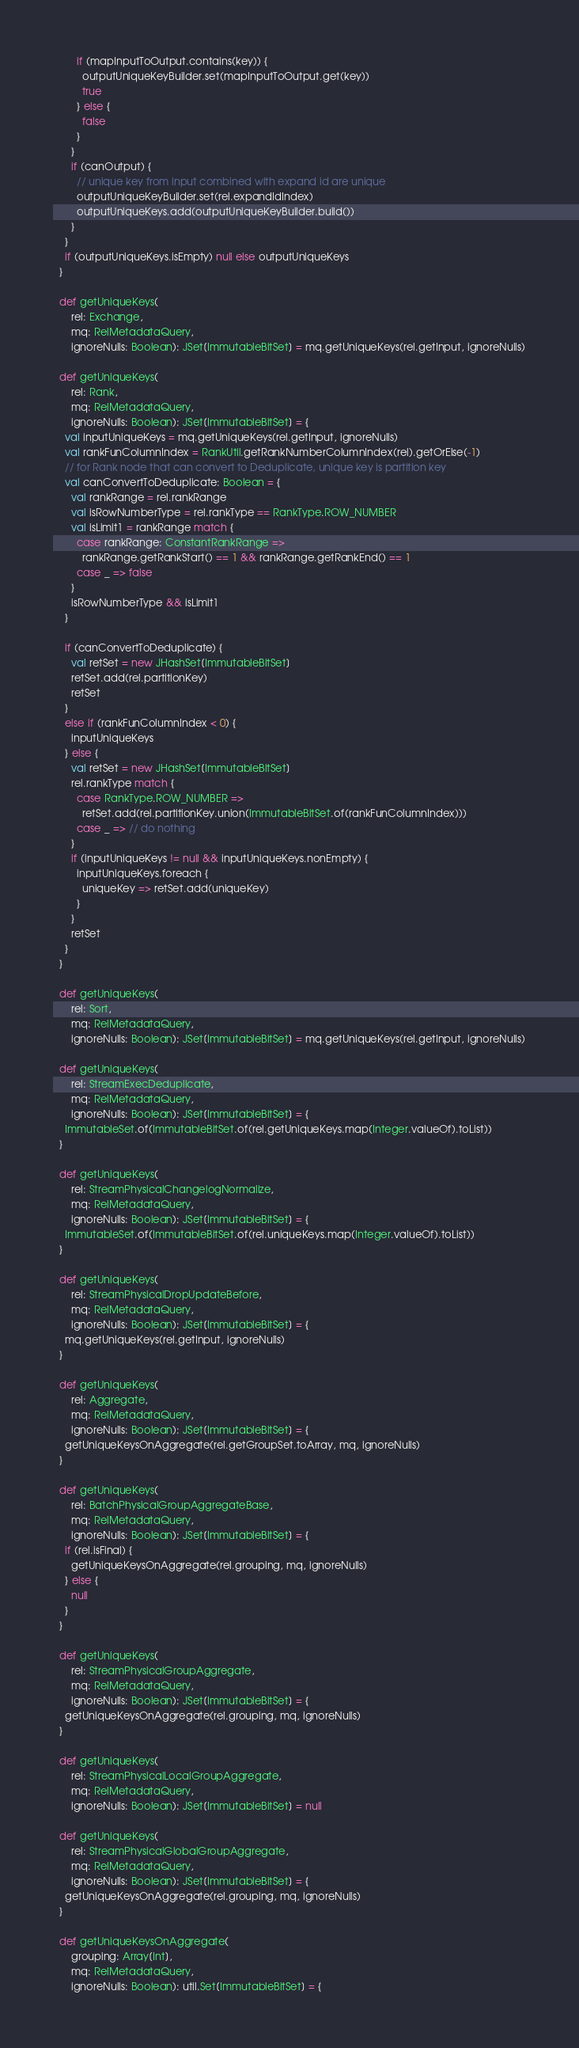Convert code to text. <code><loc_0><loc_0><loc_500><loc_500><_Scala_>        if (mapInputToOutput.contains(key)) {
          outputUniqueKeyBuilder.set(mapInputToOutput.get(key))
          true
        } else {
          false
        }
      }
      if (canOutput) {
        // unique key from input combined with expand id are unique
        outputUniqueKeyBuilder.set(rel.expandIdIndex)
        outputUniqueKeys.add(outputUniqueKeyBuilder.build())
      }
    }
    if (outputUniqueKeys.isEmpty) null else outputUniqueKeys
  }

  def getUniqueKeys(
      rel: Exchange,
      mq: RelMetadataQuery,
      ignoreNulls: Boolean): JSet[ImmutableBitSet] = mq.getUniqueKeys(rel.getInput, ignoreNulls)

  def getUniqueKeys(
      rel: Rank,
      mq: RelMetadataQuery,
      ignoreNulls: Boolean): JSet[ImmutableBitSet] = {
    val inputUniqueKeys = mq.getUniqueKeys(rel.getInput, ignoreNulls)
    val rankFunColumnIndex = RankUtil.getRankNumberColumnIndex(rel).getOrElse(-1)
    // for Rank node that can convert to Deduplicate, unique key is partition key
    val canConvertToDeduplicate: Boolean = {
      val rankRange = rel.rankRange
      val isRowNumberType = rel.rankType == RankType.ROW_NUMBER
      val isLimit1 = rankRange match {
        case rankRange: ConstantRankRange =>
          rankRange.getRankStart() == 1 && rankRange.getRankEnd() == 1
        case _ => false
      }
      isRowNumberType && isLimit1
    }

    if (canConvertToDeduplicate) {
      val retSet = new JHashSet[ImmutableBitSet]
      retSet.add(rel.partitionKey)
      retSet
    }
    else if (rankFunColumnIndex < 0) {
      inputUniqueKeys
    } else {
      val retSet = new JHashSet[ImmutableBitSet]
      rel.rankType match {
        case RankType.ROW_NUMBER =>
          retSet.add(rel.partitionKey.union(ImmutableBitSet.of(rankFunColumnIndex)))
        case _ => // do nothing
      }
      if (inputUniqueKeys != null && inputUniqueKeys.nonEmpty) {
        inputUniqueKeys.foreach {
          uniqueKey => retSet.add(uniqueKey)
        }
      }
      retSet
    }
  }

  def getUniqueKeys(
      rel: Sort,
      mq: RelMetadataQuery,
      ignoreNulls: Boolean): JSet[ImmutableBitSet] = mq.getUniqueKeys(rel.getInput, ignoreNulls)

  def getUniqueKeys(
      rel: StreamExecDeduplicate,
      mq: RelMetadataQuery,
      ignoreNulls: Boolean): JSet[ImmutableBitSet] = {
    ImmutableSet.of(ImmutableBitSet.of(rel.getUniqueKeys.map(Integer.valueOf).toList))
  }

  def getUniqueKeys(
      rel: StreamPhysicalChangelogNormalize,
      mq: RelMetadataQuery,
      ignoreNulls: Boolean): JSet[ImmutableBitSet] = {
    ImmutableSet.of(ImmutableBitSet.of(rel.uniqueKeys.map(Integer.valueOf).toList))
  }

  def getUniqueKeys(
      rel: StreamPhysicalDropUpdateBefore,
      mq: RelMetadataQuery,
      ignoreNulls: Boolean): JSet[ImmutableBitSet] = {
    mq.getUniqueKeys(rel.getInput, ignoreNulls)
  }

  def getUniqueKeys(
      rel: Aggregate,
      mq: RelMetadataQuery,
      ignoreNulls: Boolean): JSet[ImmutableBitSet] = {
    getUniqueKeysOnAggregate(rel.getGroupSet.toArray, mq, ignoreNulls)
  }

  def getUniqueKeys(
      rel: BatchPhysicalGroupAggregateBase,
      mq: RelMetadataQuery,
      ignoreNulls: Boolean): JSet[ImmutableBitSet] = {
    if (rel.isFinal) {
      getUniqueKeysOnAggregate(rel.grouping, mq, ignoreNulls)
    } else {
      null
    }
  }

  def getUniqueKeys(
      rel: StreamPhysicalGroupAggregate,
      mq: RelMetadataQuery,
      ignoreNulls: Boolean): JSet[ImmutableBitSet] = {
    getUniqueKeysOnAggregate(rel.grouping, mq, ignoreNulls)
  }

  def getUniqueKeys(
      rel: StreamPhysicalLocalGroupAggregate,
      mq: RelMetadataQuery,
      ignoreNulls: Boolean): JSet[ImmutableBitSet] = null

  def getUniqueKeys(
      rel: StreamPhysicalGlobalGroupAggregate,
      mq: RelMetadataQuery,
      ignoreNulls: Boolean): JSet[ImmutableBitSet] = {
    getUniqueKeysOnAggregate(rel.grouping, mq, ignoreNulls)
  }

  def getUniqueKeysOnAggregate(
      grouping: Array[Int],
      mq: RelMetadataQuery,
      ignoreNulls: Boolean): util.Set[ImmutableBitSet] = {</code> 